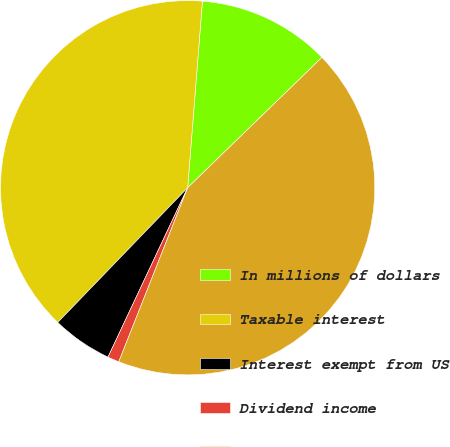Convert chart to OTSL. <chart><loc_0><loc_0><loc_500><loc_500><pie_chart><fcel>In millions of dollars<fcel>Taxable interest<fcel>Interest exempt from US<fcel>Dividend income<fcel>Total interest and dividend<nl><fcel>11.48%<fcel>39.05%<fcel>5.21%<fcel>1.0%<fcel>43.26%<nl></chart> 